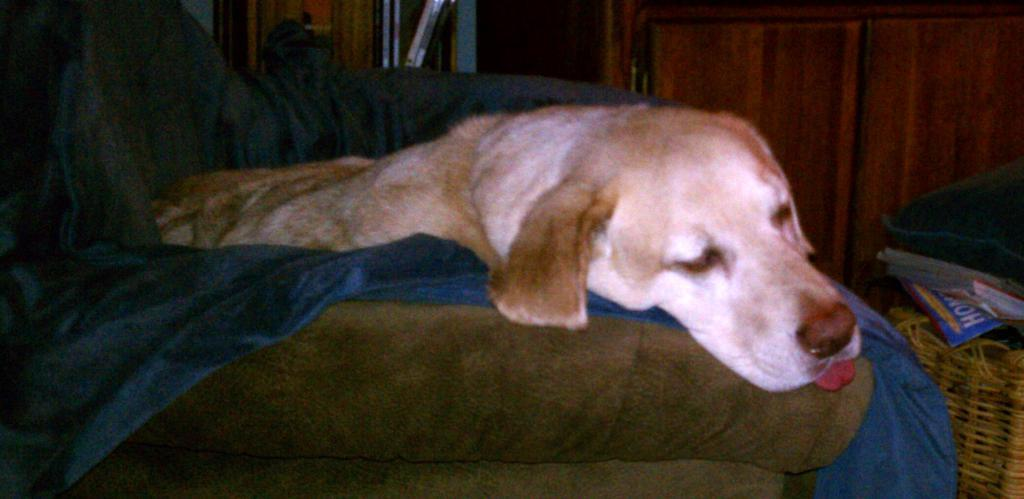What type of animal is present in the image? There is a dog in the image. What is the dog lying on in the image? There is a blanket in the image. What is the dog resting in or near in the image? There is a basket in the image. What is placed on the basket in the image? There are objects on the basket. How many chairs are visible in the image? There are no chairs present in the image. What type of support does the dog provide in the image? The dog is not providing any support in the image; it is resting on a blanket in a basket. 